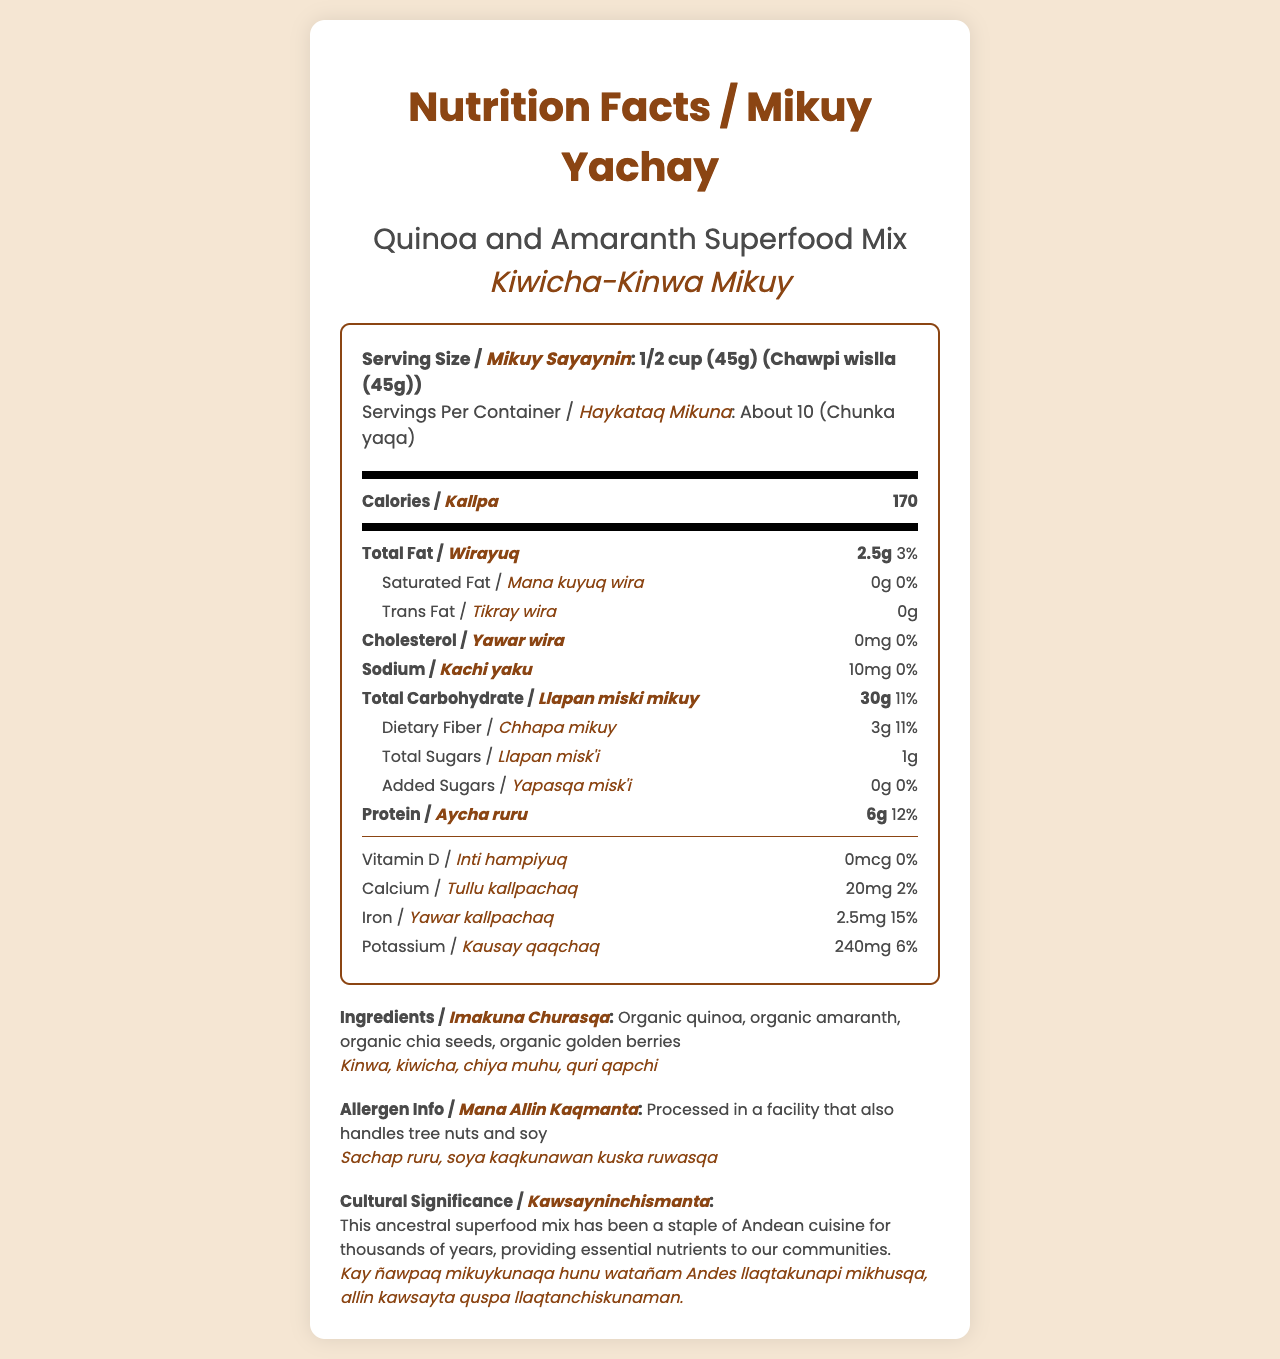what is the serving size in English? The document states that the serving size is "1/2 cup (45g)" in the "Serving Size" section.
Answer: 1/2 cup (45g) what is the serving size in Quechua? The document states that the serving size in Quechua is "Chawpi wislla (45g)" in the "Serving Size" section.
Answer: Chawpi wislla (45g) how many servings are there per container? The "Servings Per Container" section states "About 10" servings per container.
Answer: About 10 how many calories are in one serving? The "Calories" section shows that there are 170 calories in one serving.
Answer: 170 how much total fat is in one serving (in grams)? The document lists the total fat content as "2.5g" in the "Total Fat" section.
Answer: 2.5g What is the cultural significance described for this product? The "Cultural Significance" section provides this description.
Answer: This ancestral superfood mix has been a staple of Andean cuisine for thousands of years, providing essential nutrients to our communities. what is the Quechua term for cholesterol? The document lists "Yawar wira" as the Quechua term for cholesterol in the "Cholesterol" section.
Answer: Yawar wira how many grams of dietary fiber are in one serving? The "Dietary Fiber" section states that there are 3 grams of dietary fiber per serving.
Answer: 3g what allergens might be present in this product? The "Allergen Info" section mentions that the product is processed in a facility that also handles tree nuts and soy.
Answer: Tree nuts and soy which of the following vitamins or minerals is not present in this product?
A. Vitamin D
B. Calcium
C. Iron The document indicates there is 0 mcg of Vitamin D in the product, whereas calcium and iron have positive values.
Answer: A. Vitamin D how many grams of protein are in one serving?
A. 4g
B. 5g
C. 6g
D. 7g The "Protein" section shows that there are 6 grams of protein in one serving.
Answer: C. 6g True or False: The product contains added sugars. The "Added Sugars" section indicates that there are 0 grams of added sugars in the product.
Answer: False summarize the main idea of the document. This summarizes the main sections and content of the document, highlighting the key nutritional values and cultural context.
Answer: The document is a Nutrition Facts label for a Quinoa and Amaranth Superfood Mix, providing detailed nutritional information, ingredients, allergen information, and cultural significance, with translations in Quechua. which traditional indigenous superfoods are included in this mix? The ingredients list mentions "organic quinoa, organic amaranth, organic chia seeds, organic golden berries," but it doesn't specify which of these are considered traditional indigenous superfoods.
Answer: Cannot be determined 